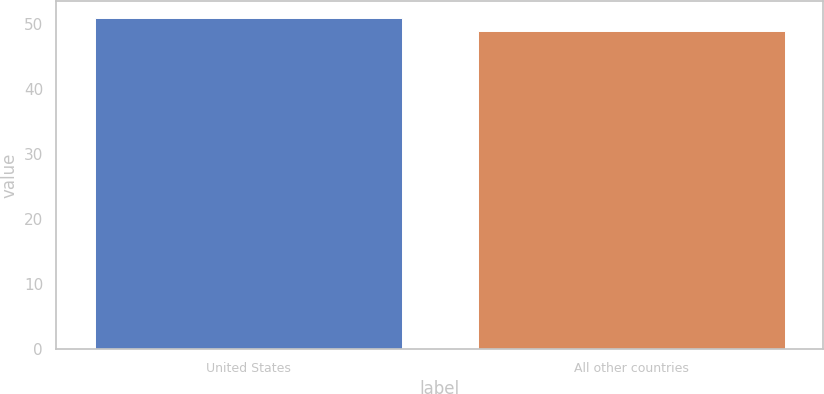Convert chart. <chart><loc_0><loc_0><loc_500><loc_500><bar_chart><fcel>United States<fcel>All other countries<nl><fcel>51<fcel>49<nl></chart> 